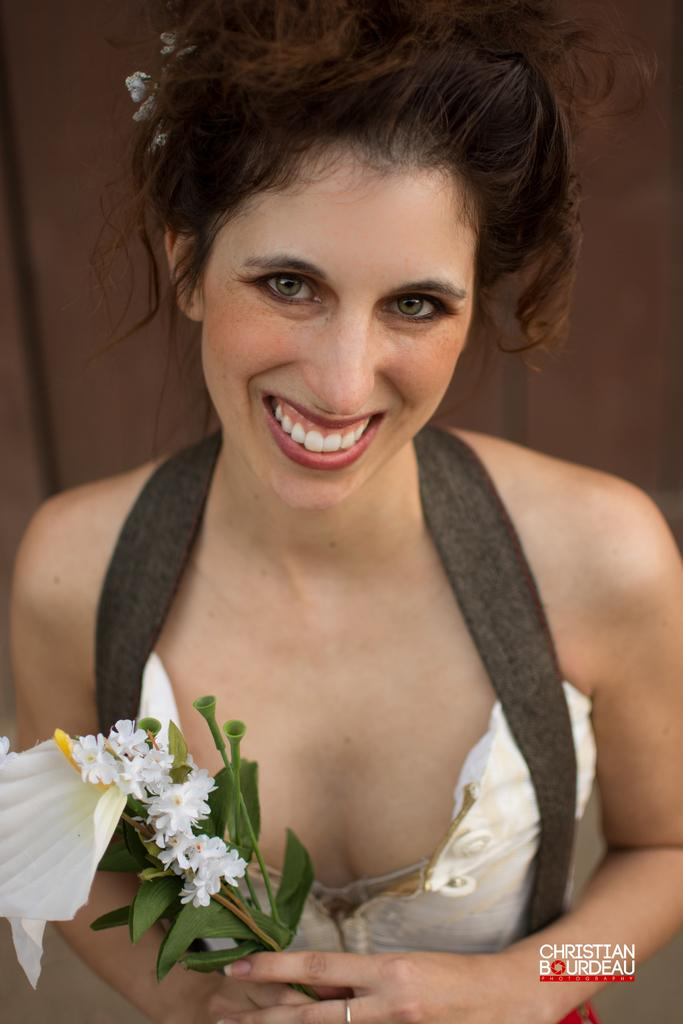Who is the main subject in the image? There is a woman in the image. What is the woman holding in the image? The woman is holding a flower bouquet. What is the woman's facial expression in the image? The woman is smiling. Can you describe any additional features of the image? There is a watermark at the bottom of the image. What color is the kitty that the woman is petting in the image? There is no kitty present in the image; the woman is holding a flower bouquet and smiling. 